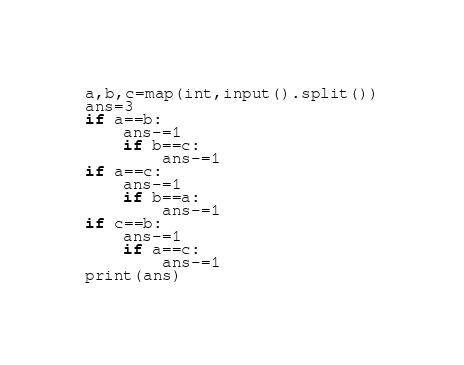Convert code to text. <code><loc_0><loc_0><loc_500><loc_500><_Python_>a,b,c=map(int,input().split())
ans=3
if a==b:
    ans-=1
    if b==c:
        ans-=1
if a==c:
    ans-=1
    if b==a:
        ans-=1
if c==b:
    ans-=1
    if a==c:
        ans-=1
print(ans)       
</code> 